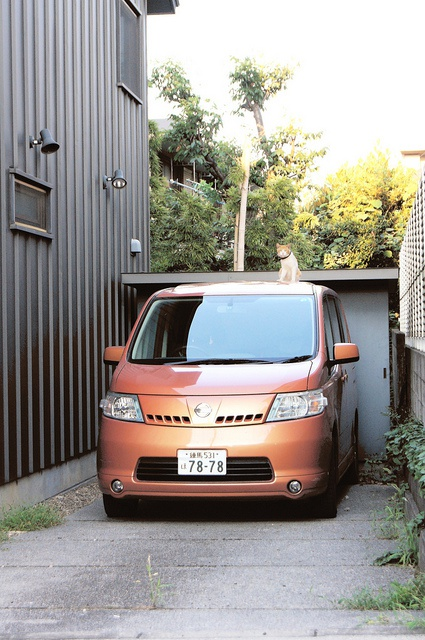Describe the objects in this image and their specific colors. I can see car in darkgray, black, white, lightblue, and brown tones and cat in darkgray, lightgray, and tan tones in this image. 